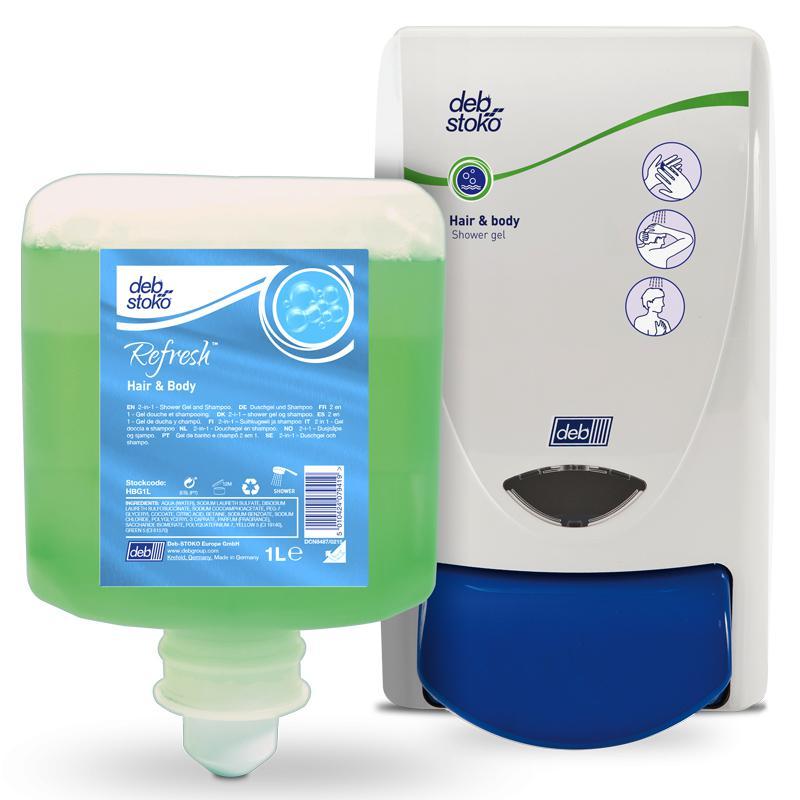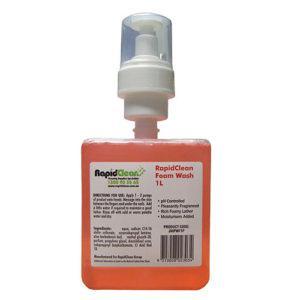The first image is the image on the left, the second image is the image on the right. For the images displayed, is the sentence "There are more than two dispensers." factually correct? Answer yes or no. No. The first image is the image on the left, the second image is the image on the right. Analyze the images presented: Is the assertion "There are exactly three visible containers of soap, two in one image and one in the other." valid? Answer yes or no. Yes. 